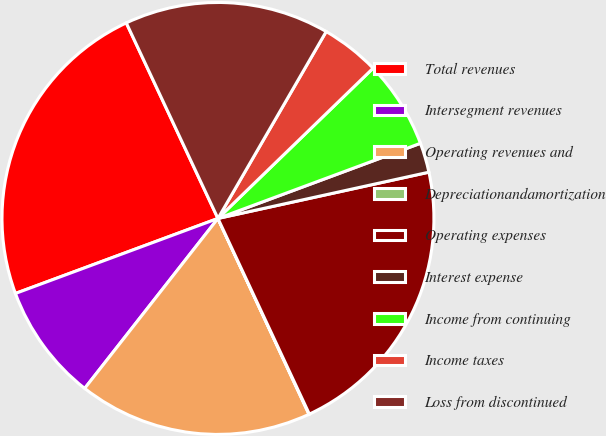<chart> <loc_0><loc_0><loc_500><loc_500><pie_chart><fcel>Total revenues<fcel>Intersegment revenues<fcel>Operating revenues and<fcel>Depreciationandamortization<fcel>Operating expenses<fcel>Interest expense<fcel>Income from continuing<fcel>Income taxes<fcel>Loss from discontinued<nl><fcel>23.67%<fcel>8.77%<fcel>17.51%<fcel>0.03%<fcel>21.48%<fcel>2.22%<fcel>6.59%<fcel>4.4%<fcel>15.33%<nl></chart> 